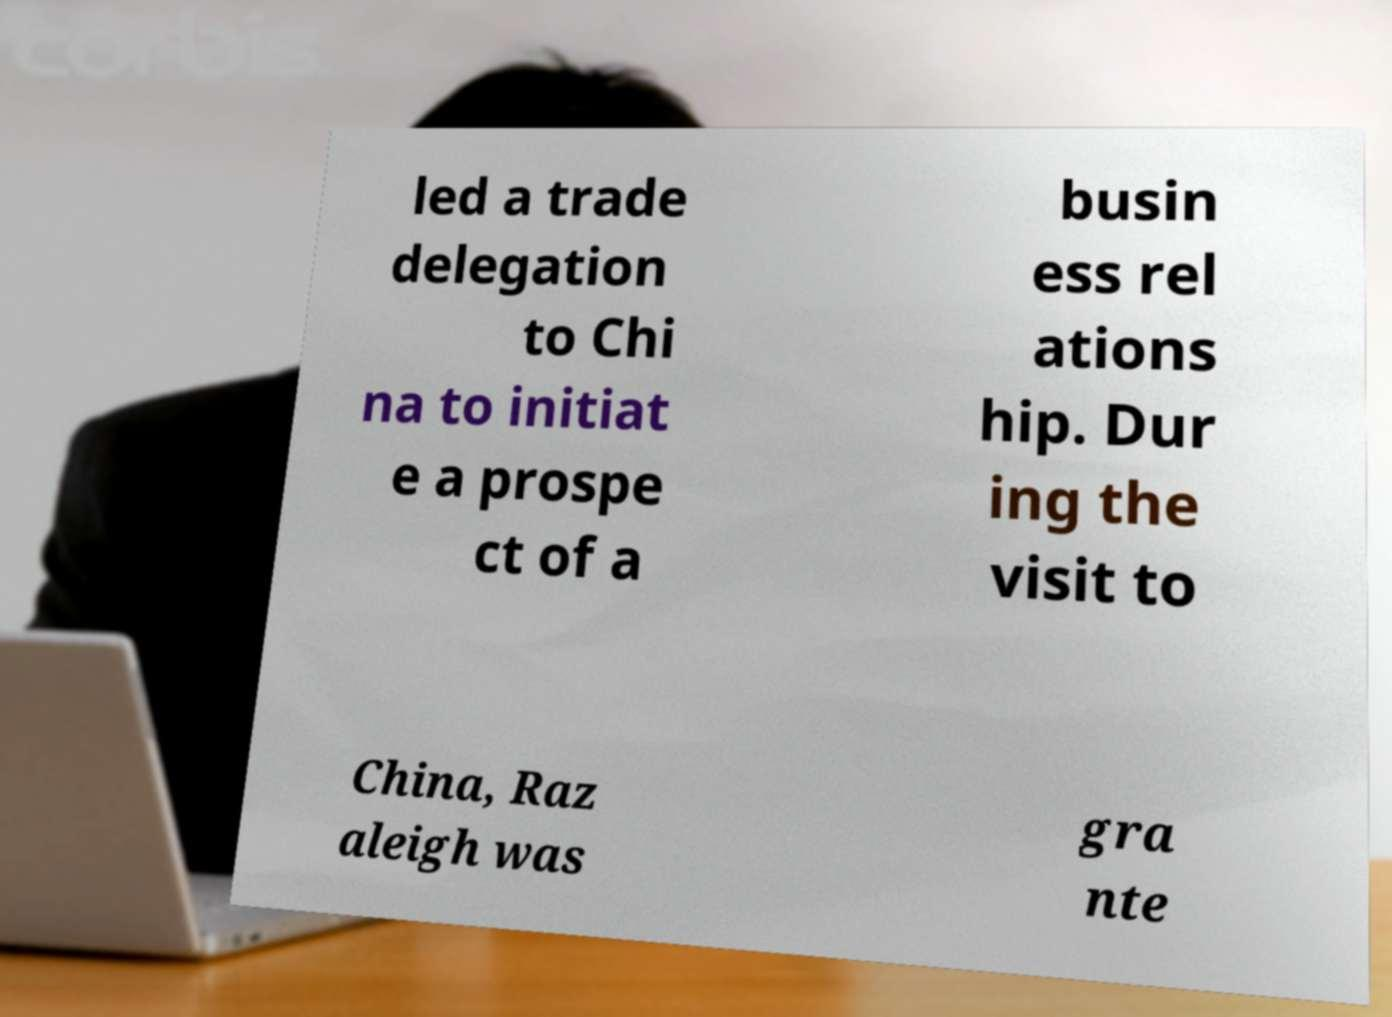Could you assist in decoding the text presented in this image and type it out clearly? led a trade delegation to Chi na to initiat e a prospe ct of a busin ess rel ations hip. Dur ing the visit to China, Raz aleigh was gra nte 